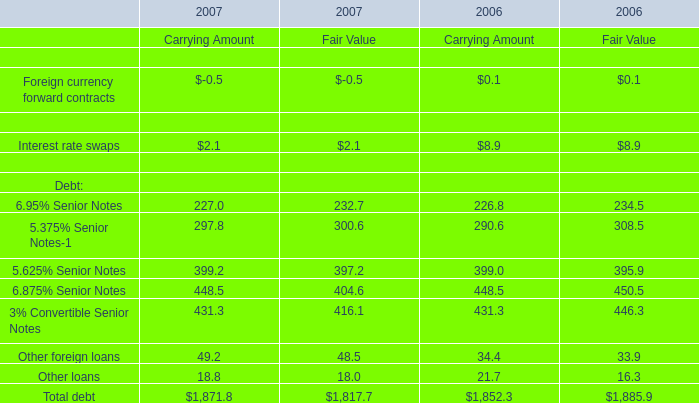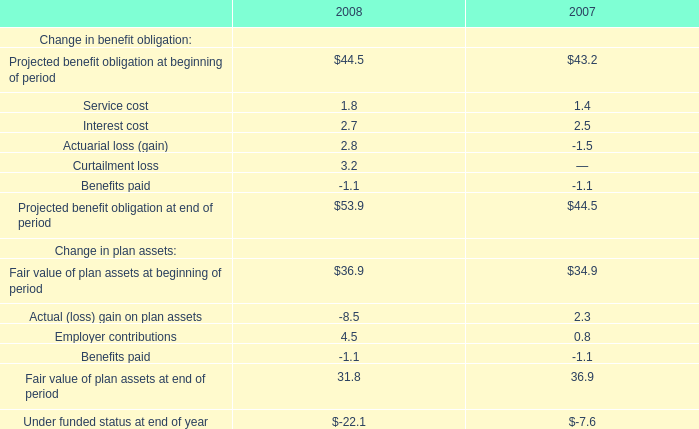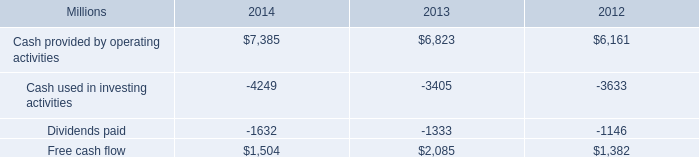Does Other foreign loans for Carrying Amount keeps increasing each year between 2006 and 2007? 
Answer: Yes. 